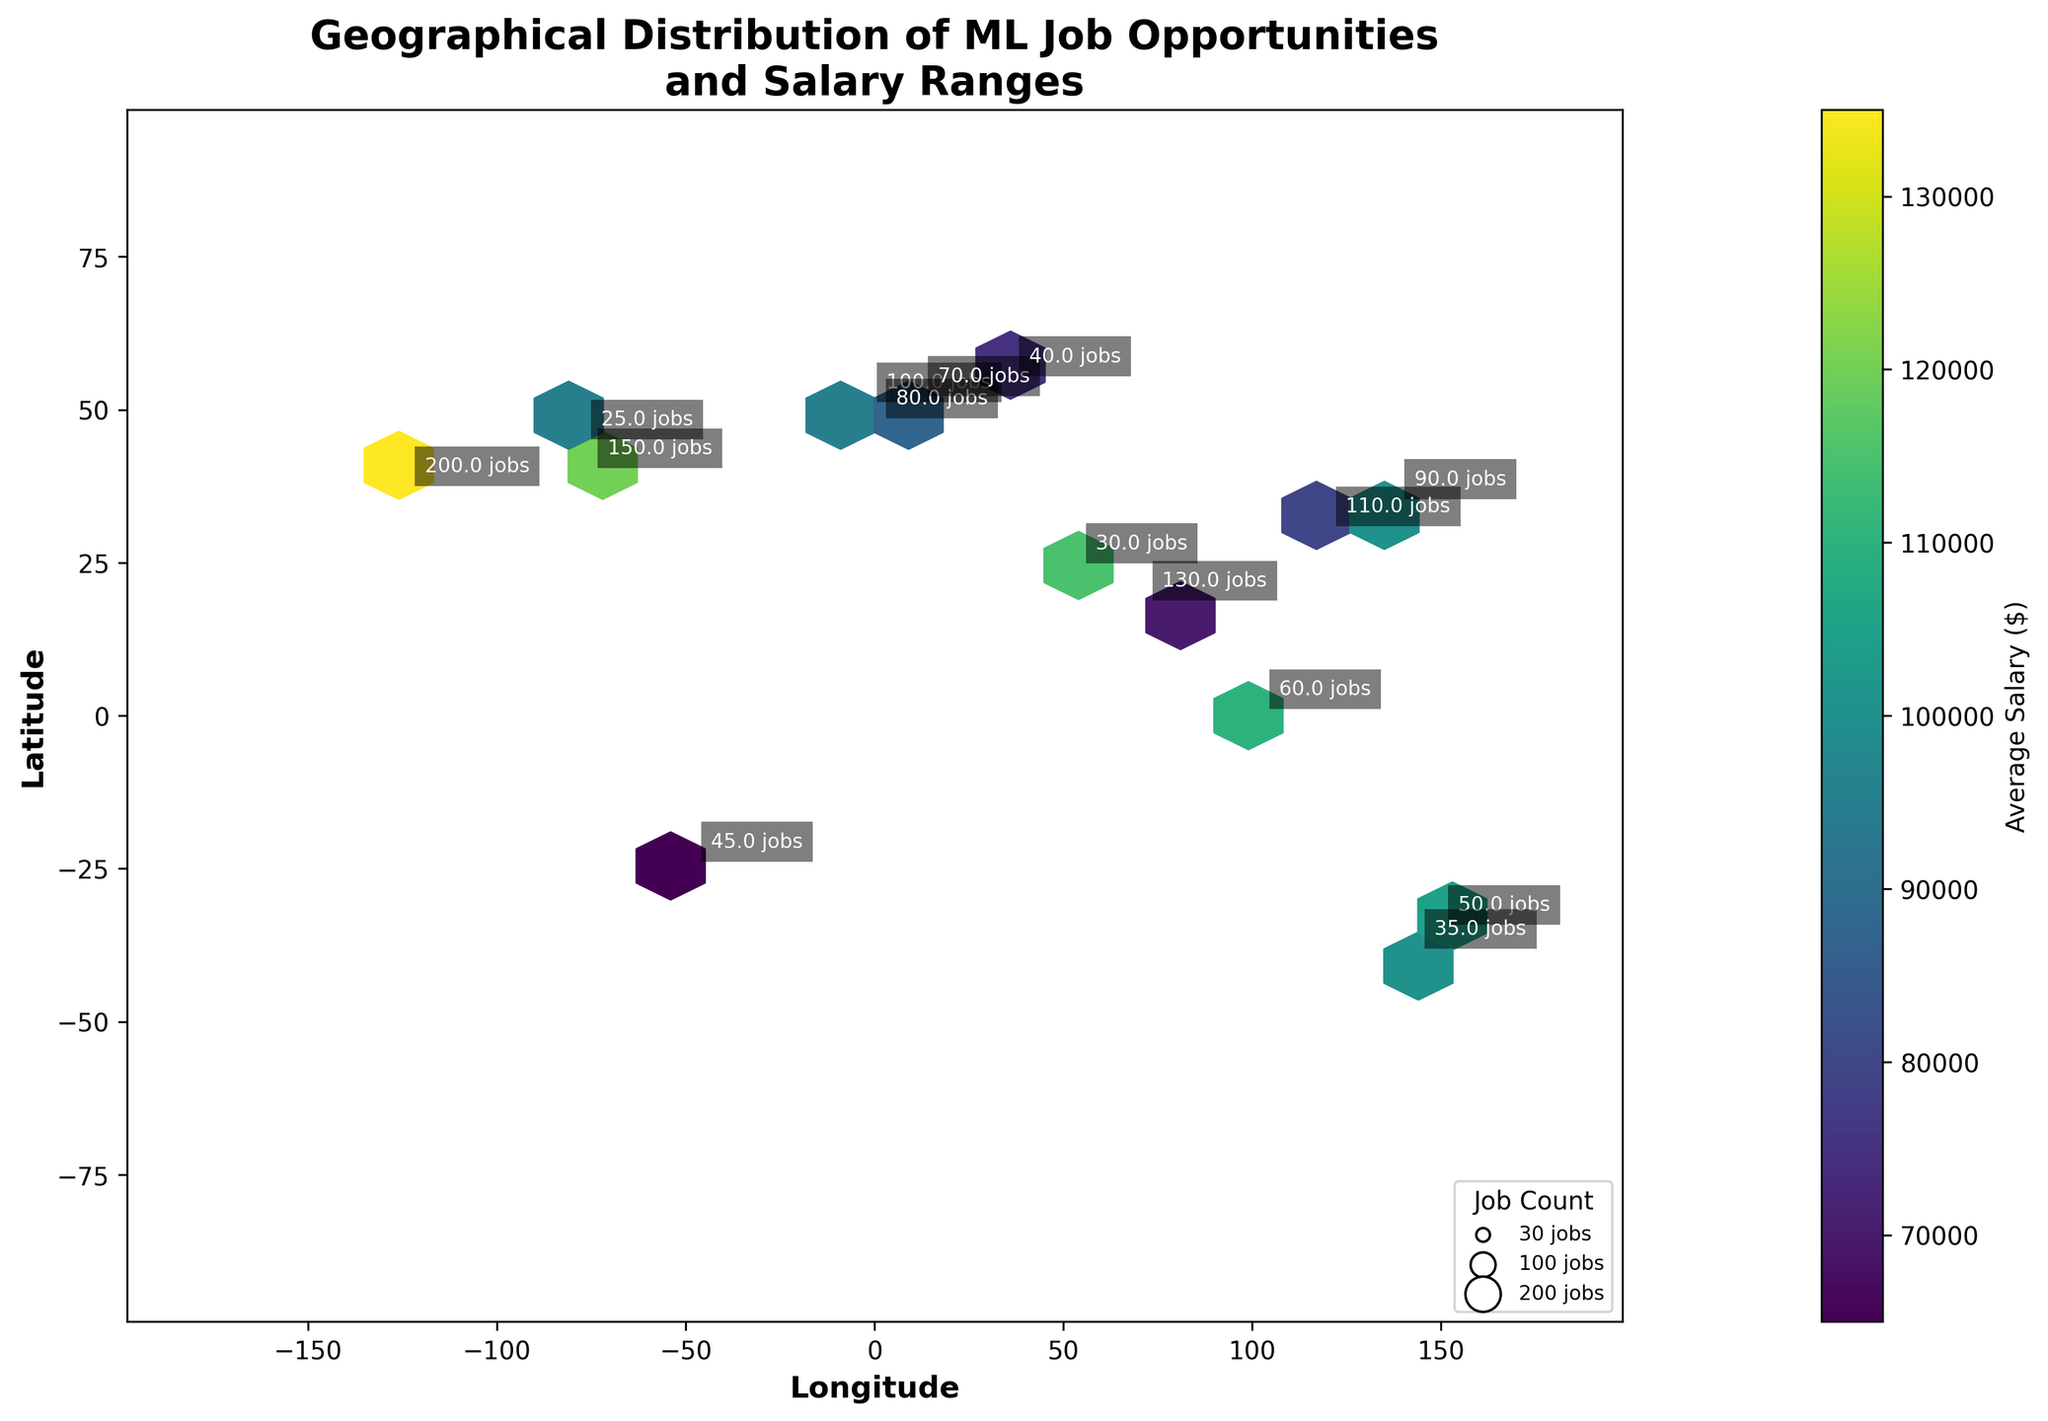Which city has the highest number of machine learning jobs? By observing the annotations in the figure, we can identify that San Francisco (Longitude: -122.4194, Latitude: 37.7749) has 200 machine learning job opportunities.
Answer: San Francisco Which city offers the highest average salary for machine learning jobs? By examining the color shading and confirming with annotations, we find that San Francisco (Longitude: -122.4194, Latitude: 37.7749) offers the highest average salary of $135,000.
Answer: San Francisco How does the average salary in Tokyo compare with that in London? By looking at the respective annotations, Tokyo (Longitude: 139.6503, Latitude: 35.6762) has an average salary of $100,000, whereas London (Longitude: -0.1278, Latitude: 51.5074) has an average salary of $95,000. Thus, Tokyo offers a higher average salary than London.
Answer: Tokyo has a higher salary Which city has the lowest average salary for machine learning jobs? By referencing the color scale and annotations, São Paulo (Longitude: -46.6333, Latitude: -23.5505) is identified as having the lowest average salary of $65,000.
Answer: São Paulo In which geographical region (considering both longitude and latitude) is the concentration of machine learning jobs the highest? By observing the density and annotations on the Hexbin Plot map, we can see that the highest concentration of machine learning jobs is in the western region of the United States, particularly around San Francisco (Longitude: -122.4194, Latitude: 37.7749).
Answer: Western USA (San Francisco) Is there a noticeable difference in the concentration of job opportunities between the Northern and Southern Hemispheres? By comparing the density of hexagons and job annotations above and below the equator, it is evident that the Northern Hemisphere, particularly cities like San Francisco, New York, and London, has a higher concentration of job opportunities than the Southern Hemisphere.
Answer: Higher in Northern Hemisphere Which region has a higher concentration of high-paying machine learning jobs: Europe or North America? By looking at the color shading and density of hexagons, North America, specifically around San Francisco, shows a higher concentration of high-paying jobs compared to Europe.
Answer: North America How many jobs are available in Singapore, and what is the average salary there? The annotation for Singapore (Longitude: 103.8198, Latitude: 1.3521) indicates there are 60 job opportunities with an average salary of $110,000.
Answer: 60 jobs, $110,000 What is the average salary for machine learning jobs in cities that have more than 100 job opportunities? Identifying cities with more than 100 job opportunities (New York, San Francisco, Mumbai), we calculate their average salary as follows: 
New York (120,000) + San Francisco (135,000) + Mumbai (70,000) = 325,000 / 3 cities = $108,333.33.
Answer: $108,333.33 Which cities have less than 50 machine learning job opportunities? From the annotations, cities with less than 50 job opportunities are: Dubai (30), São Paulo (45), Moscow (40), and Ottawa (25).
Answer: Dubai, São Paulo, Moscow, Ottawa 